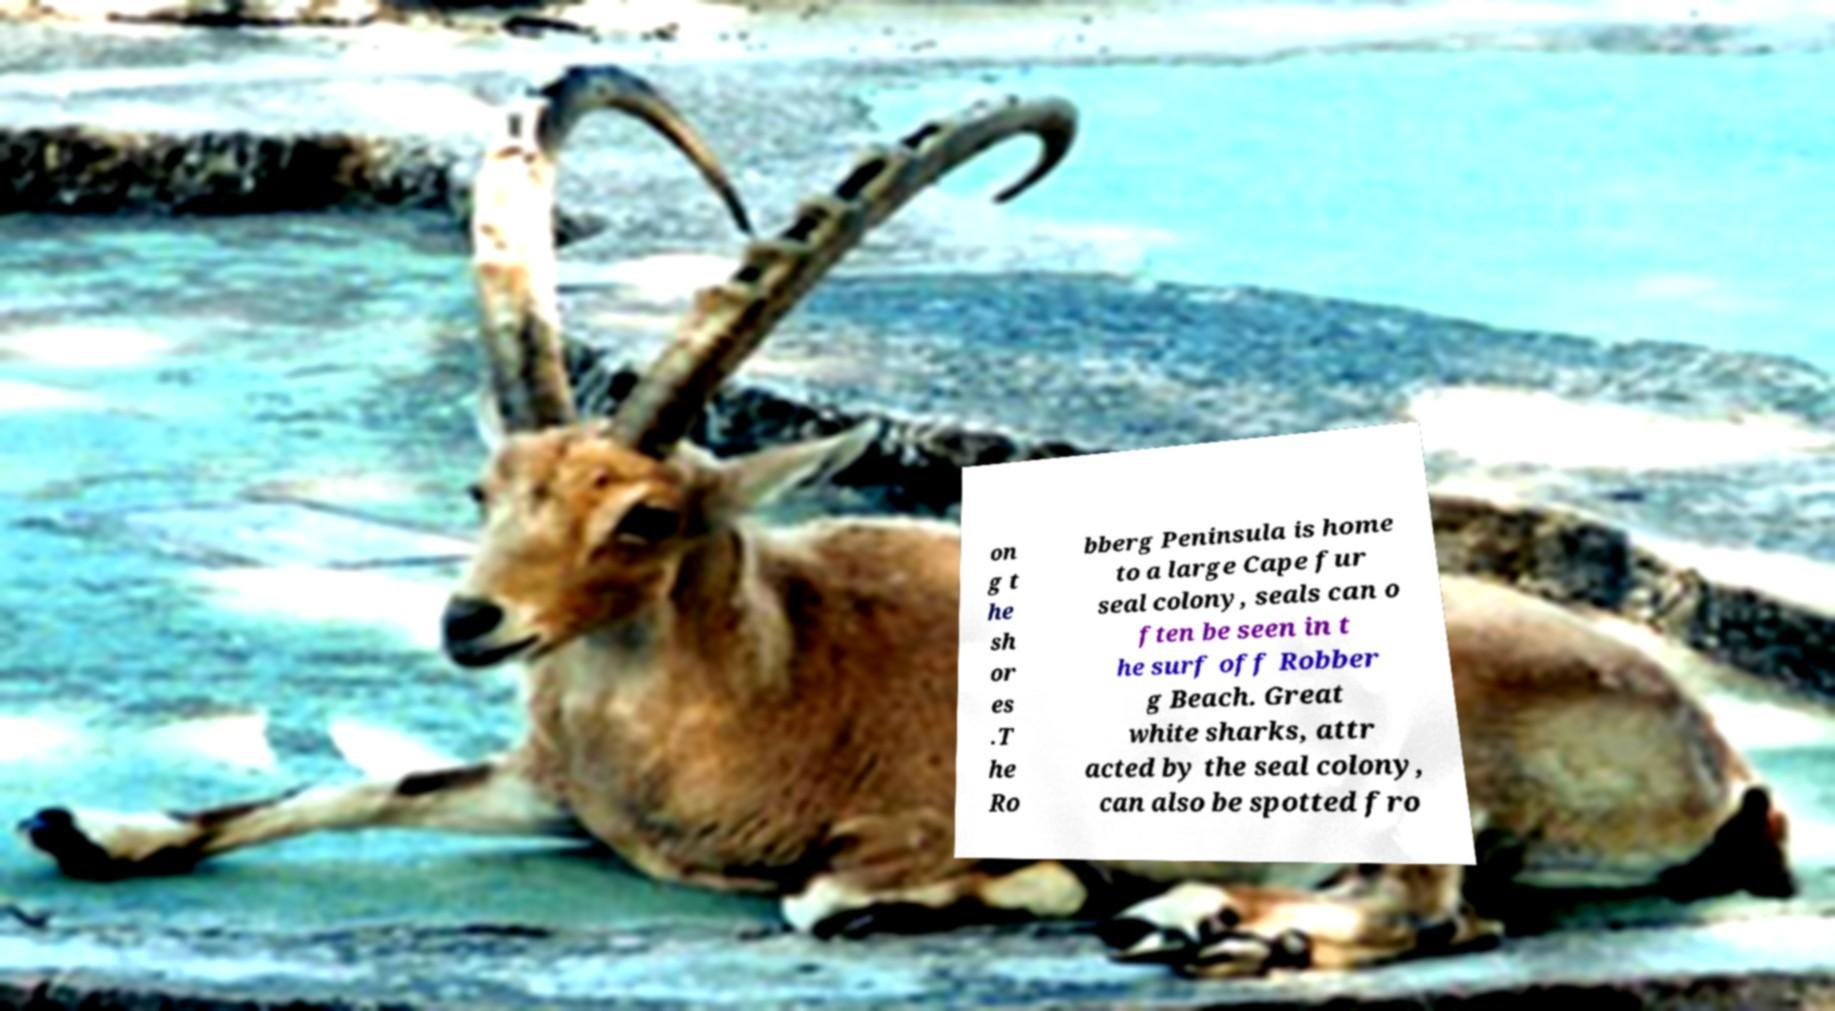Could you assist in decoding the text presented in this image and type it out clearly? on g t he sh or es .T he Ro bberg Peninsula is home to a large Cape fur seal colony, seals can o ften be seen in t he surf off Robber g Beach. Great white sharks, attr acted by the seal colony, can also be spotted fro 